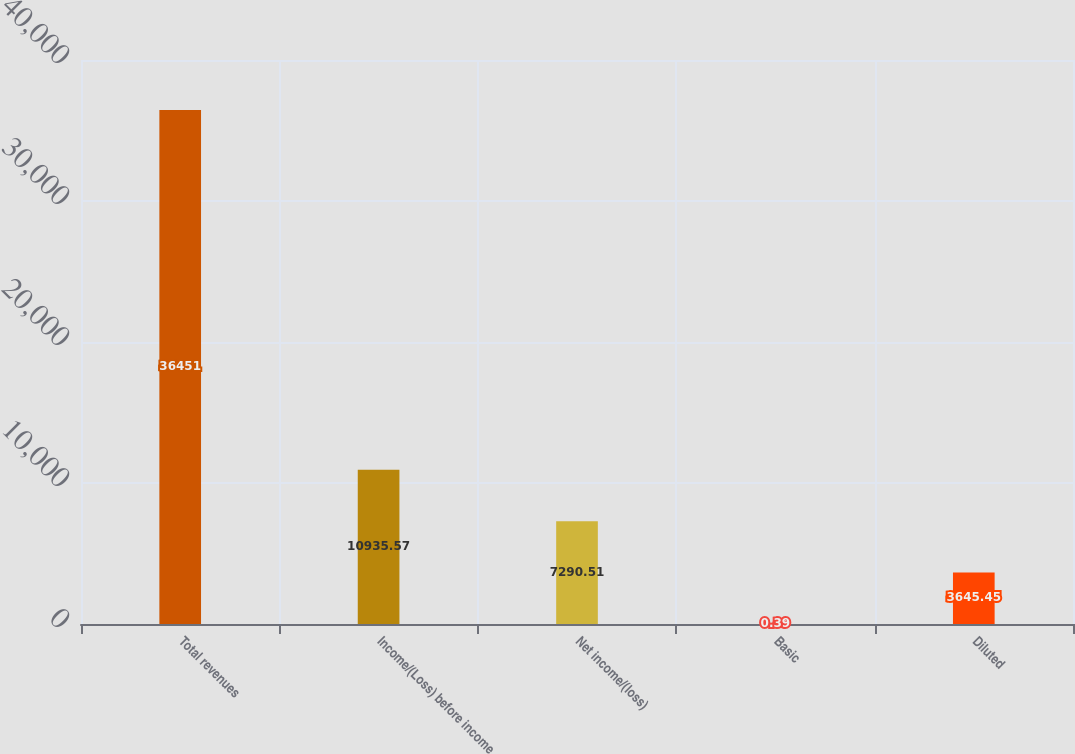Convert chart to OTSL. <chart><loc_0><loc_0><loc_500><loc_500><bar_chart><fcel>Total revenues<fcel>Income/(Loss) before income<fcel>Net income/(loss)<fcel>Basic<fcel>Diluted<nl><fcel>36451<fcel>10935.6<fcel>7290.51<fcel>0.39<fcel>3645.45<nl></chart> 